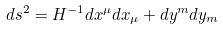Convert formula to latex. <formula><loc_0><loc_0><loc_500><loc_500>d s ^ { 2 } = H ^ { - 1 } d x ^ { \mu } d x _ { \mu } + d y ^ { m } d y _ { m }</formula> 